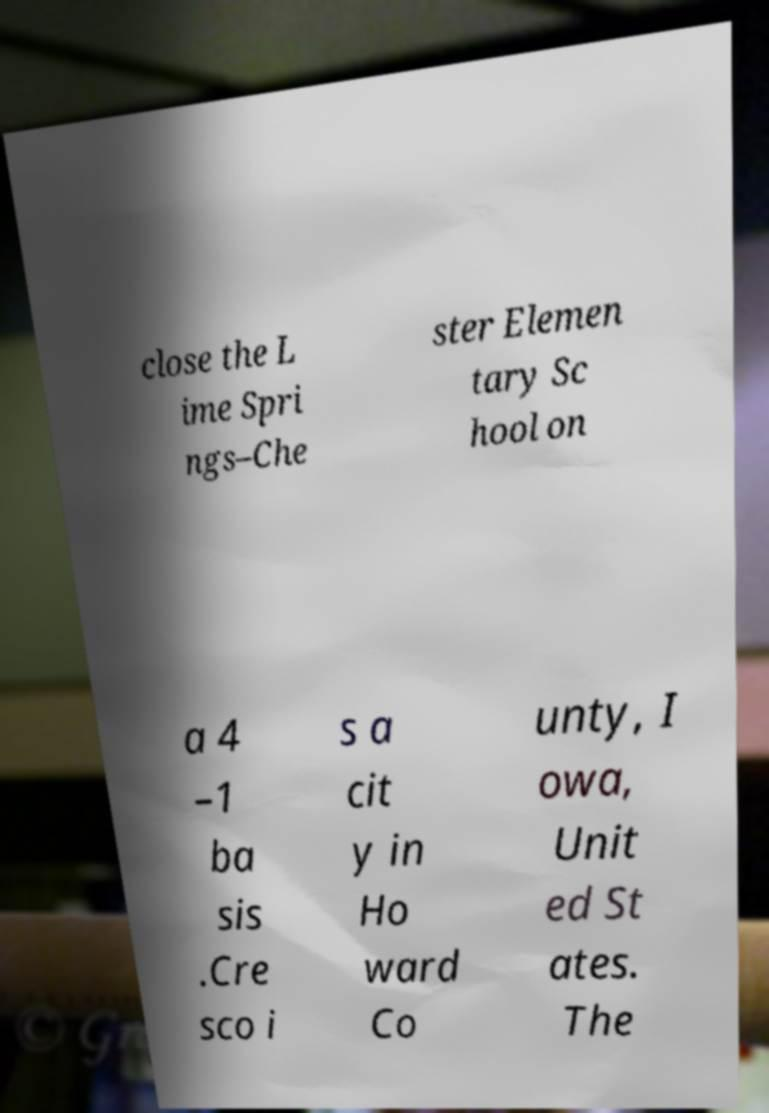Please identify and transcribe the text found in this image. close the L ime Spri ngs–Che ster Elemen tary Sc hool on a 4 –1 ba sis .Cre sco i s a cit y in Ho ward Co unty, I owa, Unit ed St ates. The 